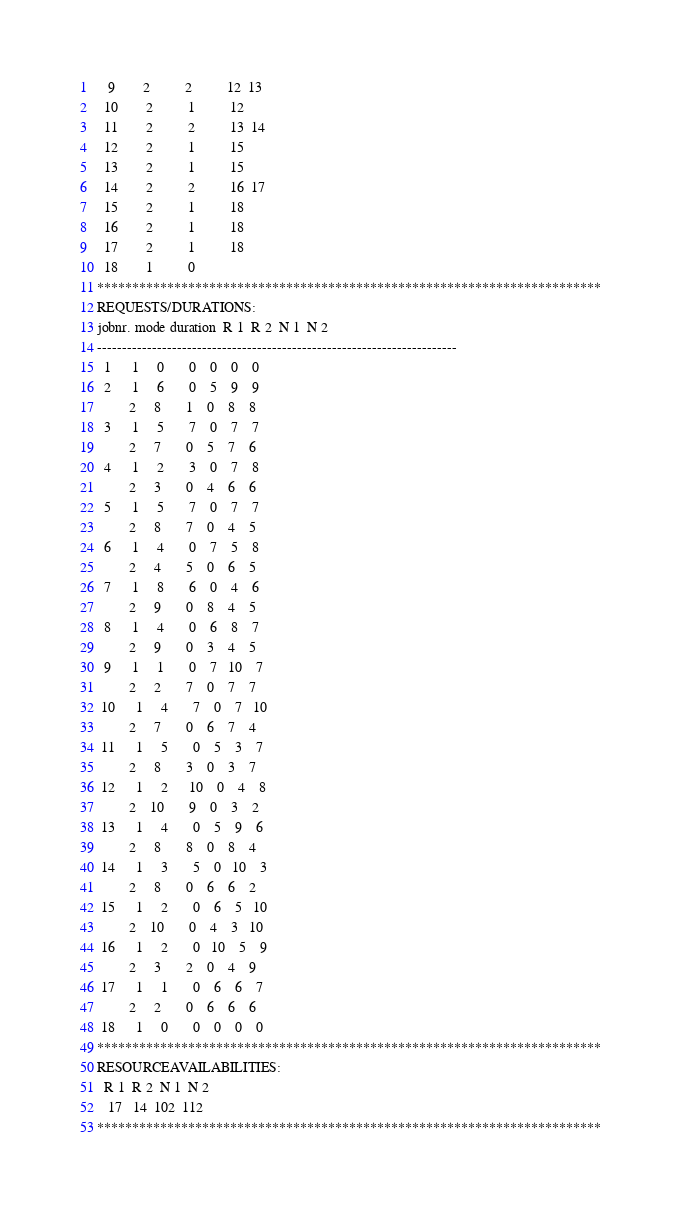<code> <loc_0><loc_0><loc_500><loc_500><_ObjectiveC_>   9        2          2          12  13
  10        2          1          12
  11        2          2          13  14
  12        2          1          15
  13        2          1          15
  14        2          2          16  17
  15        2          1          18
  16        2          1          18
  17        2          1          18
  18        1          0        
************************************************************************
REQUESTS/DURATIONS:
jobnr. mode duration  R 1  R 2  N 1  N 2
------------------------------------------------------------------------
  1      1     0       0    0    0    0
  2      1     6       0    5    9    9
         2     8       1    0    8    8
  3      1     5       7    0    7    7
         2     7       0    5    7    6
  4      1     2       3    0    7    8
         2     3       0    4    6    6
  5      1     5       7    0    7    7
         2     8       7    0    4    5
  6      1     4       0    7    5    8
         2     4       5    0    6    5
  7      1     8       6    0    4    6
         2     9       0    8    4    5
  8      1     4       0    6    8    7
         2     9       0    3    4    5
  9      1     1       0    7   10    7
         2     2       7    0    7    7
 10      1     4       7    0    7   10
         2     7       0    6    7    4
 11      1     5       0    5    3    7
         2     8       3    0    3    7
 12      1     2      10    0    4    8
         2    10       9    0    3    2
 13      1     4       0    5    9    6
         2     8       8    0    8    4
 14      1     3       5    0   10    3
         2     8       0    6    6    2
 15      1     2       0    6    5   10
         2    10       0    4    3   10
 16      1     2       0   10    5    9
         2     3       2    0    4    9
 17      1     1       0    6    6    7
         2     2       0    6    6    6
 18      1     0       0    0    0    0
************************************************************************
RESOURCEAVAILABILITIES:
  R 1  R 2  N 1  N 2
   17   14  102  112
************************************************************************
</code> 